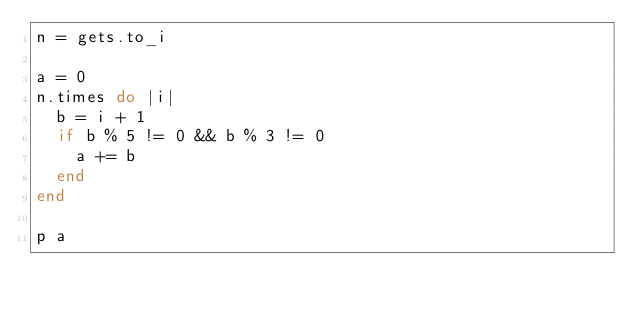Convert code to text. <code><loc_0><loc_0><loc_500><loc_500><_Ruby_>n = gets.to_i

a = 0
n.times do |i|
  b = i + 1
  if b % 5 != 0 && b % 3 != 0
    a += b
  end
end

p a</code> 